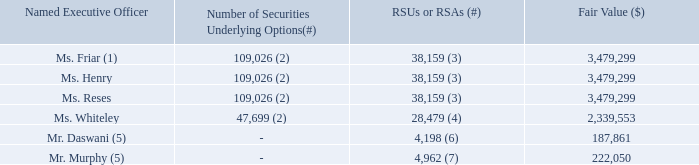In 2018, we granted new equity awards to our named executive officers described in the table below. In determining the size and terms of these equity awards for Mses. Friar, Henry, Reses and Whiteley, our compensation committee, with input from our CEO, our then-current People Lead and Compensia, considered the past and expected future key contributions of each of these named executive officers, the extent to which their existing equity awards were vested and the competitive market data for similarly situated executives. Our compensation committee believed it was appropriate to grant each of them new equity awards to help achieve our retention goals and further align their compensation with the competitive market.
(1) Ms. Friar resigned from her position as Chief Financial Officer, effective as of November 16, 2018.
(2) One-twelfth of 10% of the shares subject to the option vest in equal monthly installments over one year from April 1, 2018, and one-thirty-sixth of 90% of the shares subject to the option vest in equal monthly installments over three years from April 1, 2019, subject to continued service with us.
(3) 2.5% of RSAs vest in four equal quarterly installments over one year from April 1, 2018, and 7.5% RSUs vest in 12 quarterly installments over three years from April 1, 2019, subject to continued service with us.
(4) With respect to 16,695 of the total RSAs, 2.5% of RSAs vest in four equal quarterly installments over one year from April 1, 2018, and 7.5% RSUs vest in 12 quarterly installments over three years from April 1, 2019, subject to continued service with us. And, with respect to 11,784 of the total RSAs, one-sixteenth of RSAs vest in 16 equal quarterly installments over four years from October 1, 2018, subject to continued service with us.
(5) Messrs. Daswani and Murphy did not receive any additional equity awards in conjunction with their service as interim co-CFOs. Equity awards to Messrs. Daswani and Murphy were granted equity awards in April 2018, prior to their becoming named executive officers, as part of the company-wide compensation review program. Their grants were recommended by their direct manager, reviewed by the then-current People Lead and approved by our compensation committee.
(6) With respect to 1,336 of the total RSAs, one-sixteenth of RSAs vest in 16 equal quarterly installments over four years from April 1, 2018, subject to continued service with us. And, with respect to 2,862 of the total RSAs, 2.5% of RSAs vest in four equal quarterly installments over one year from April 1, 2018, and 7.5% RSUs vest in 12 quarterly installments over three years from April 1, 2019, subject to continued service with us.
(7) With respect to 1,527 of the total RSAs, one-sixteenth of RSAs vest in 16 equal quarterly installments over four years from April 1, 2018, subject to continued service with us. And, with respect to 3,435 of the total RSAs, 2.5% of RSAs vest in four equal quarterly installments over one year from April 1, 2018, and 7.5% RSUs vest in 12 quarterly installments over three years from April 1, 2019, subject to continued service with us.
Mr. Dorsey did not receive any equity awards in 2018 at his request, and because our compensation committee believed that his existing equity ownership position sufficiently aligned his interests with those of our stockholders.
Why didn’t Mr. Dorsey receive any equity awards in 2018? Because our compensation committee believed that his existing equity ownership position sufficiently aligned his interests with those of our stockholders. When did Ms. Friar resign from her position? November 16, 2018. What factors are considered in determining the size and terms of the equity awards? The past and expected future key contributions of each of these named executive officers, the extent to which their existing equity awards were vested and the competitive market data for similarly situated executives. What is the average number of securities underlying options of those executive officers who receive them? (109,026 + 109,026 + 109,026 + 47,699) / 4 
Answer: 93694.25. Which Executive Officer(s) has(have) the least number of RSUs or RSAs? From COL4 find the smallest number and the corresponding name(s) in COL2
Answer: mr. daswani. Which Executive Officer(s) has(have) the largest amount of Grant Date Fair Value? From COL5 find the largest number and the corresponding name(s) in COL2
Answer: ms. friar, ms. henry, ms. reses. 